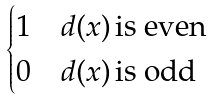<formula> <loc_0><loc_0><loc_500><loc_500>\begin{cases} 1 & d ( x ) \, \text {is even} \\ 0 & d ( x ) \, \text {is odd} \end{cases}</formula> 